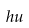Convert formula to latex. <formula><loc_0><loc_0><loc_500><loc_500>h u</formula> 